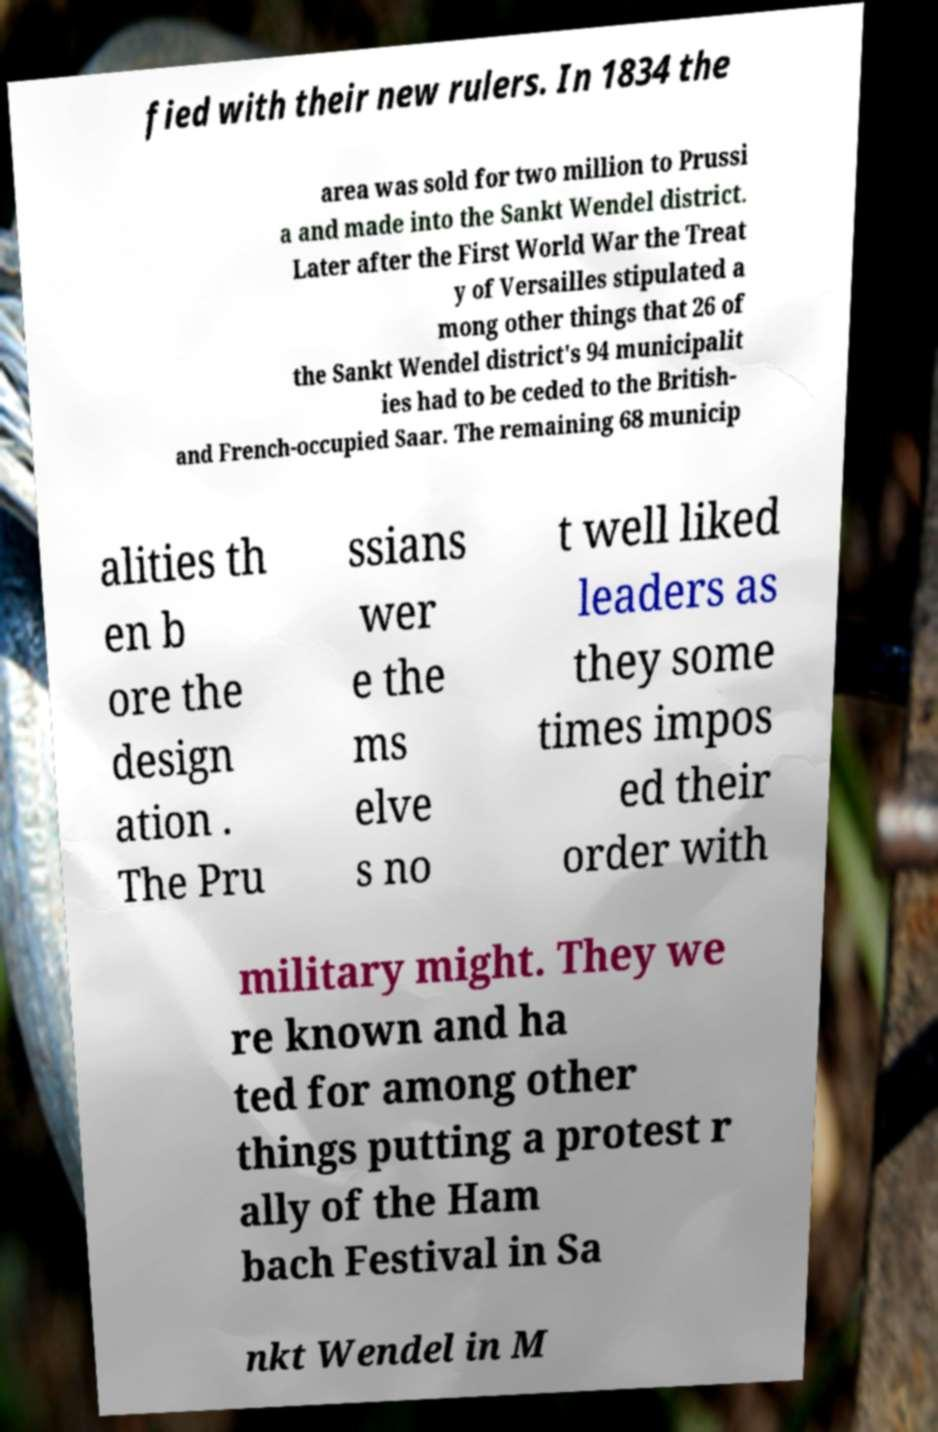Please identify and transcribe the text found in this image. fied with their new rulers. In 1834 the area was sold for two million to Prussi a and made into the Sankt Wendel district. Later after the First World War the Treat y of Versailles stipulated a mong other things that 26 of the Sankt Wendel district's 94 municipalit ies had to be ceded to the British- and French-occupied Saar. The remaining 68 municip alities th en b ore the design ation . The Pru ssians wer e the ms elve s no t well liked leaders as they some times impos ed their order with military might. They we re known and ha ted for among other things putting a protest r ally of the Ham bach Festival in Sa nkt Wendel in M 